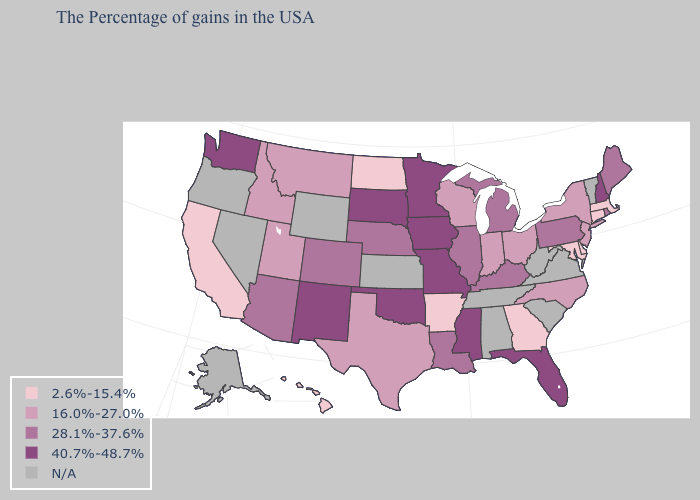Does Delaware have the lowest value in the USA?
Short answer required. Yes. What is the lowest value in states that border Colorado?
Keep it brief. 16.0%-27.0%. Is the legend a continuous bar?
Quick response, please. No. Which states hav the highest value in the MidWest?
Answer briefly. Missouri, Minnesota, Iowa, South Dakota. What is the value of Florida?
Quick response, please. 40.7%-48.7%. Which states hav the highest value in the MidWest?
Keep it brief. Missouri, Minnesota, Iowa, South Dakota. What is the value of Alaska?
Concise answer only. N/A. What is the value of New Jersey?
Short answer required. 16.0%-27.0%. Name the states that have a value in the range N/A?
Concise answer only. Vermont, Virginia, South Carolina, West Virginia, Alabama, Tennessee, Kansas, Wyoming, Nevada, Oregon, Alaska. Name the states that have a value in the range N/A?
Concise answer only. Vermont, Virginia, South Carolina, West Virginia, Alabama, Tennessee, Kansas, Wyoming, Nevada, Oregon, Alaska. What is the value of Mississippi?
Concise answer only. 40.7%-48.7%. How many symbols are there in the legend?
Short answer required. 5. Does Mississippi have the lowest value in the USA?
Concise answer only. No. Does Kentucky have the highest value in the South?
Write a very short answer. No. What is the value of Alabama?
Keep it brief. N/A. 